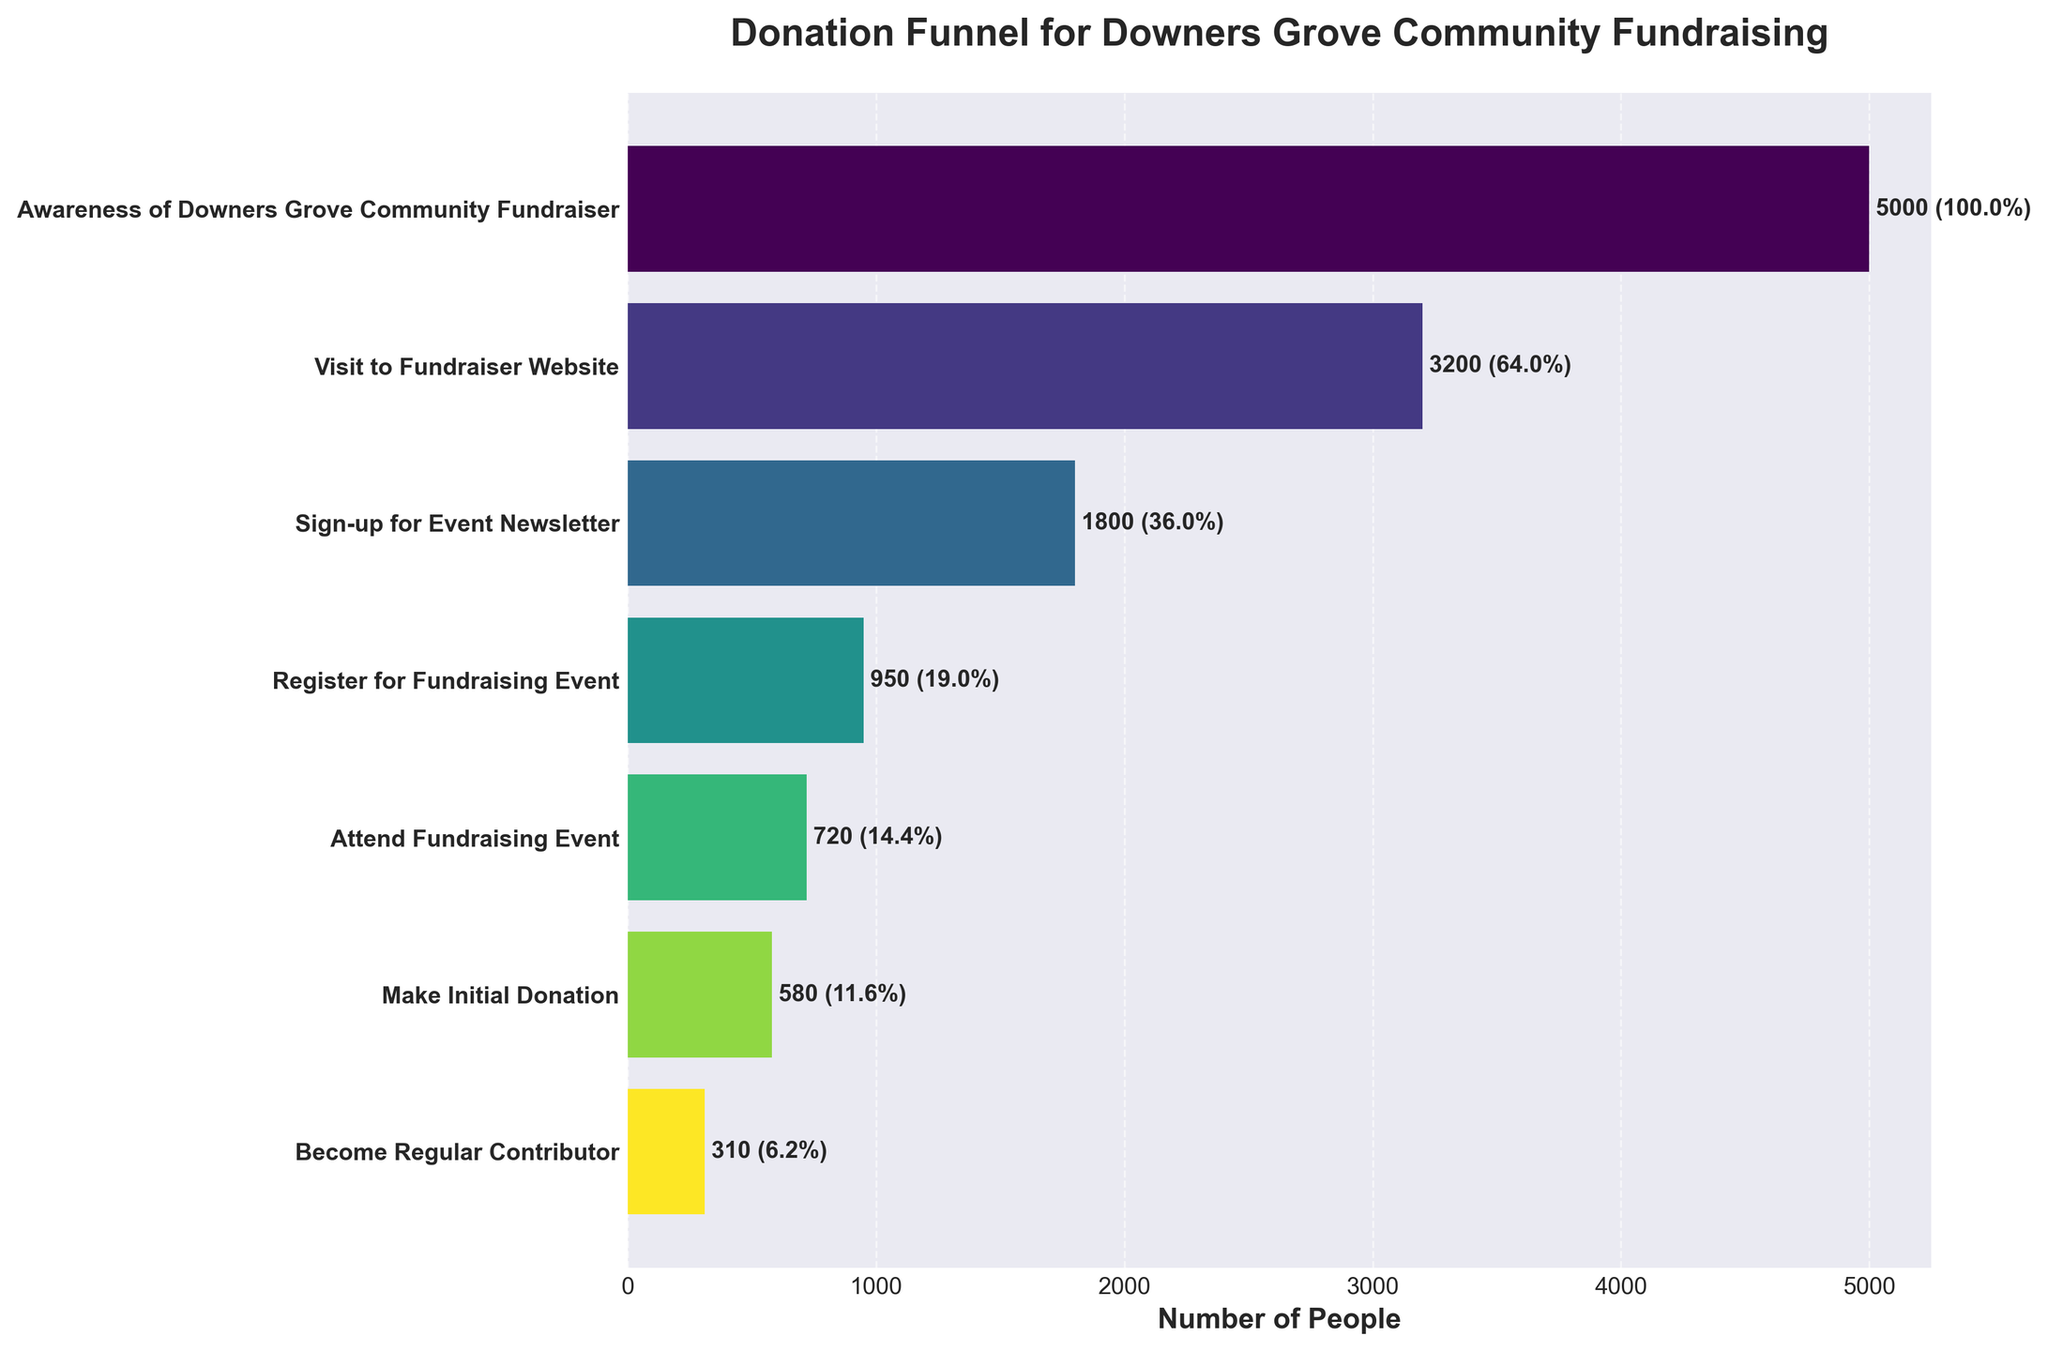How many stages are included in the donation funnel? By counting all the distinct stages listed on the y-axis, we can determine the total number of stages involved in the donation funnel.
Answer: 7 What is the number of people who registered for the fundraising event? Locate the "Register for Fundraising Event" stage on the y-axis and refer to the corresponding value on the x-axis.
Answer: 950 What percentage of people who visited the fundraiser website signed up for the event newsletter? The number of people who visited the fundraiser website is 3200, and the number who signed up for the event newsletter is 1800. The percentage can be calculated as (1800/3200) * 100%.
Answer: 56.3% How many more people attended the fundraising event than registered for it? Look at the "Register for Fundraising Event" and "Attend Fundraising Event" stages and find the values. Calculate the difference (720 - 950).
Answer: -230 Which stage had the highest drop-off rate compared to the previous stage? Compute the difference in values between each consecutive stage. Find the stage with the maximum drop-off: Awareness to Visit (5000 - 3200), Visit to Sign-up (3200 - 1800), Sign-up to Register (1800 - 950), Register to Attend (950 - 720), Attend to Initial Donation (720 - 580), Initial Donation to Regular Contributor (580 - 310).
Answer: Awareness to Visit What percentage of people who attended the fundraising event made an initial donation? The number of attendees is 720, and the number who made an initial donation is 580. Calculate the percentage as (580/720) * 100%.
Answer: 80.6% By how much did the number of people decrease from the awareness stage to becoming regular contributors? Subtract the number of regular contributors from the number of people at the awareness stage (5000 - 310).
Answer: 4690 What is the ratio of people who signed up for the event newsletter to those who became regular contributors? Divide the number of people who signed up for the event newsletter by the number of regular contributors (1800 / 310).
Answer: ~5.8 Which two consecutive stages had the closest number of participants? Find the differences between consecutive stages: Awareness to Visit (5000 - 3200), Visit to Sign-up (3200 - 1800), Sign-up to Register (1800 - 950), Register to Attend (950 - 720), Attend to Initial Donation (720 - 580), Initial Donation to Regular Contributor (580 - 310). The smallest difference indicates the closest number of participants: Attend to Initial Donation (720 - 580).
Answer: Attend to Initial Donation 